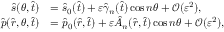Convert formula to latex. <formula><loc_0><loc_0><loc_500><loc_500>\begin{array} { r l } { \hat { s } ( \theta , \hat { t } ) } & { = \hat { s } _ { 0 } ( \hat { t } ) + \varepsilon \hat { \gamma } _ { n } ( \hat { t } ) \cos n \theta + \mathcal { O } ( \varepsilon ^ { 2 } ) , } \\ { \hat { p } ( \hat { r } , \theta , \hat { t } ) } & { = \hat { p } _ { 0 } ( \hat { r } , \hat { t } ) + \varepsilon \hat { A } _ { n } ( \hat { r } , \hat { t } ) \cos n \theta + \mathcal { O } ( \varepsilon ^ { 2 } ) , } \end{array}</formula> 